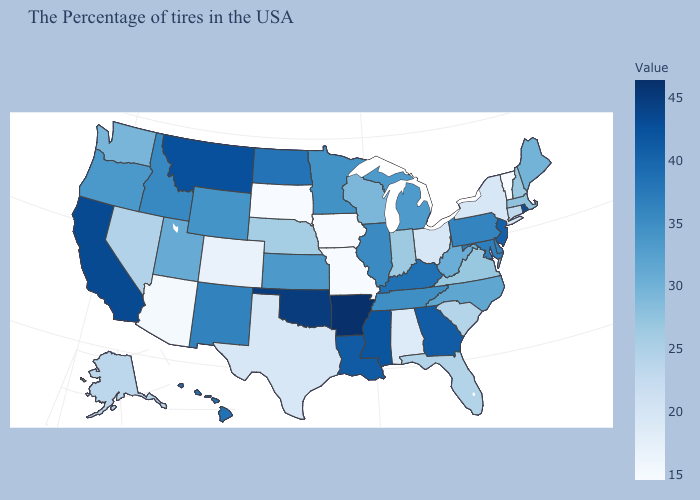Among the states that border Iowa , which have the highest value?
Write a very short answer. Illinois. Does Florida have a lower value than Texas?
Keep it brief. No. Does Arkansas have the highest value in the USA?
Keep it brief. Yes. Is the legend a continuous bar?
Write a very short answer. Yes. Among the states that border Vermont , does New York have the lowest value?
Quick response, please. Yes. Does Nevada have the lowest value in the West?
Write a very short answer. No. 